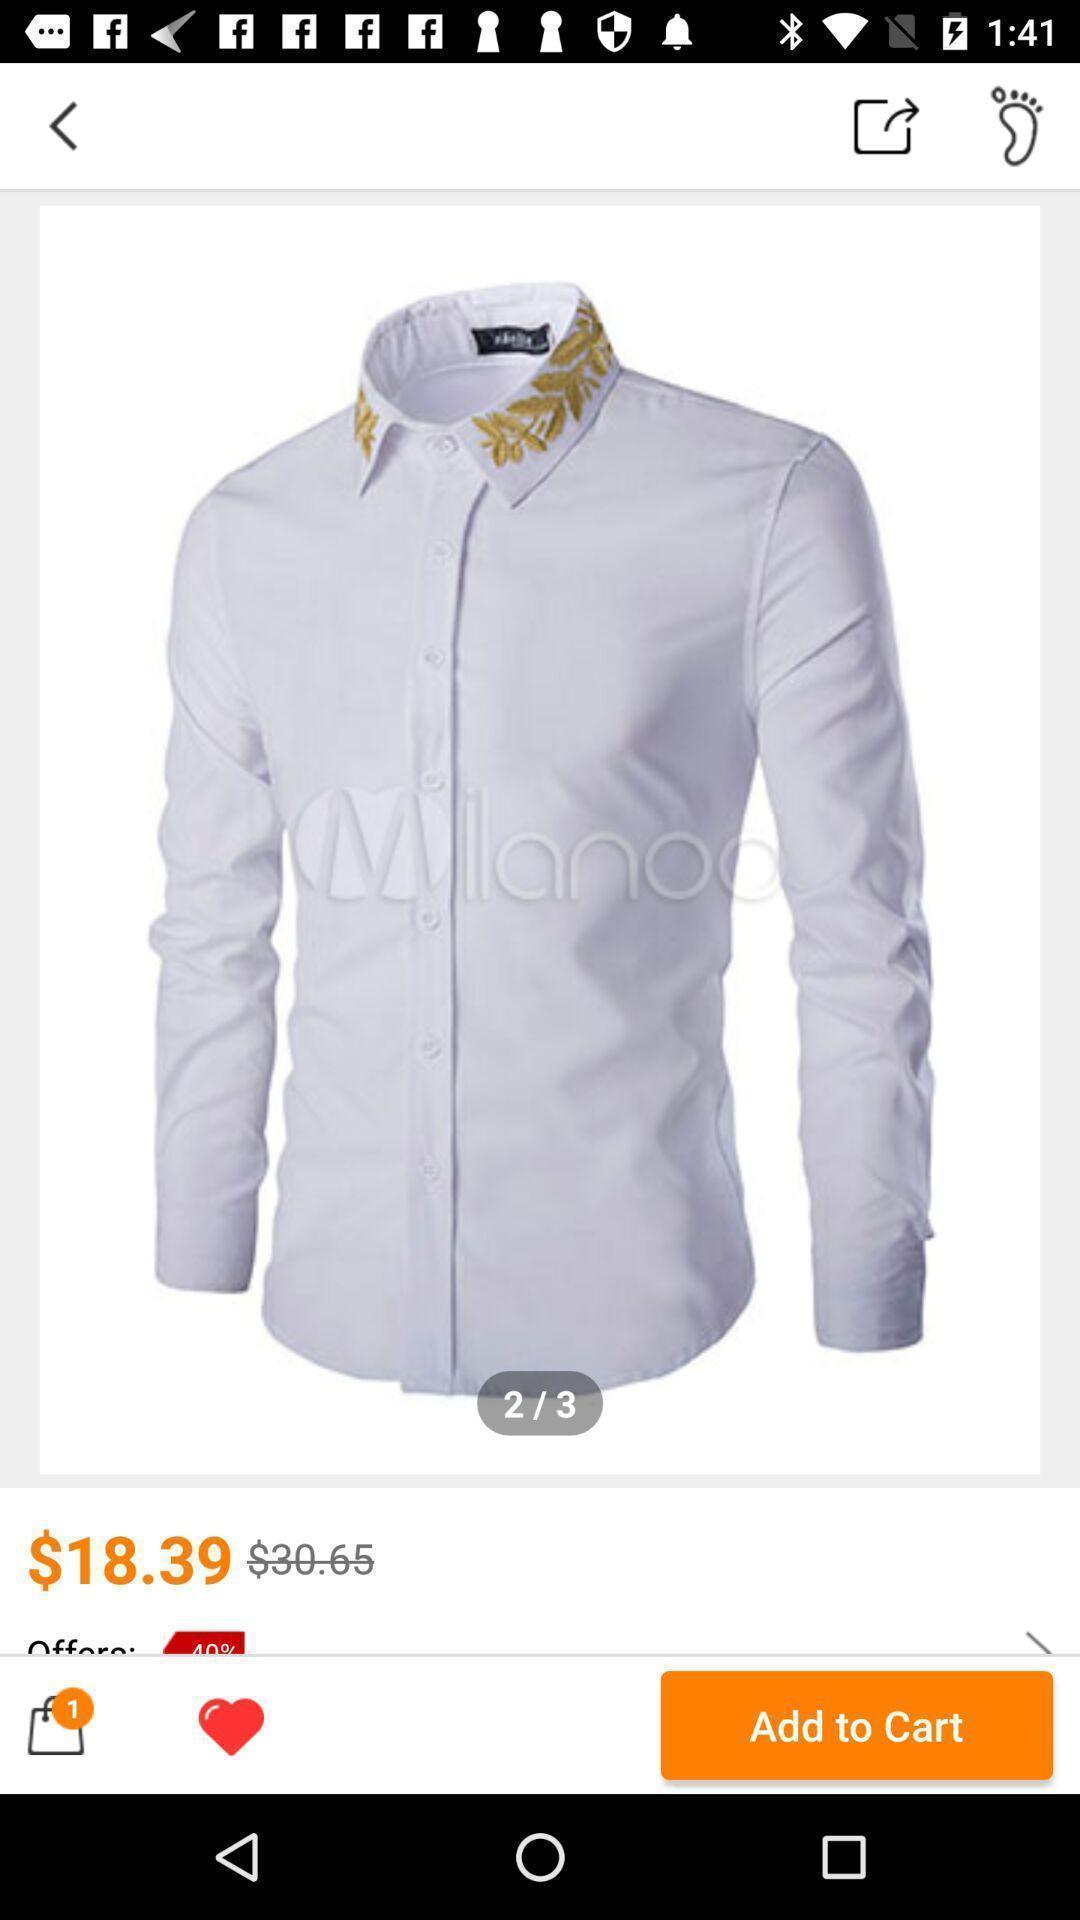Describe the content in this image. Page shows clothes in the shopping app. 